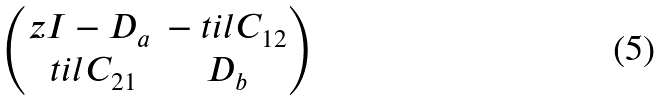<formula> <loc_0><loc_0><loc_500><loc_500>\begin{pmatrix} z I - D _ { a } & - \ t i l { C } _ { 1 2 } \\ \ t i l { C } _ { 2 1 } & D _ { b } \end{pmatrix}</formula> 